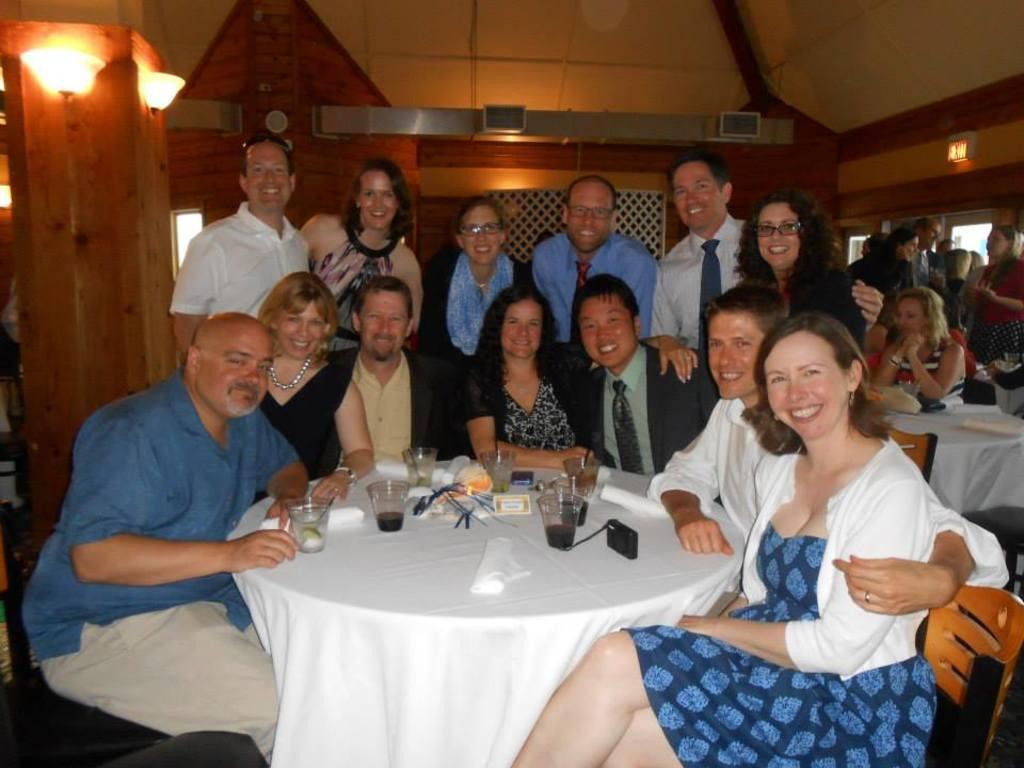What are the people in the image doing? The people in the image are sitting on chairs and standing at the back. Can you describe the positions of the people in the image? Some people are sitting on chairs, while others are standing at the back. What is the purpose of the balls in the image? There are no balls present in the image, so it is not possible to determine their purpose. 